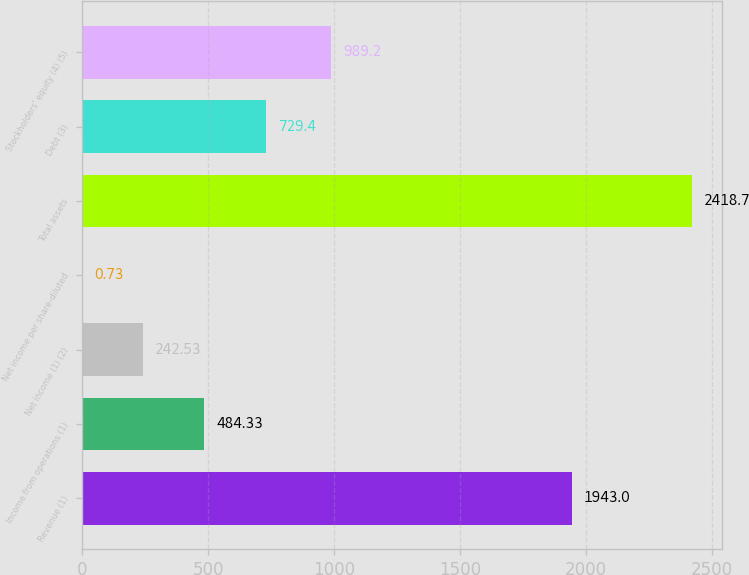Convert chart to OTSL. <chart><loc_0><loc_0><loc_500><loc_500><bar_chart><fcel>Revenue (1)<fcel>Income from operations (1)<fcel>Net income (1) (2)<fcel>Net income per share-diluted<fcel>Total assets<fcel>Debt (3)<fcel>Stockholders' equity (4) (5)<nl><fcel>1943<fcel>484.33<fcel>242.53<fcel>0.73<fcel>2418.7<fcel>729.4<fcel>989.2<nl></chart> 